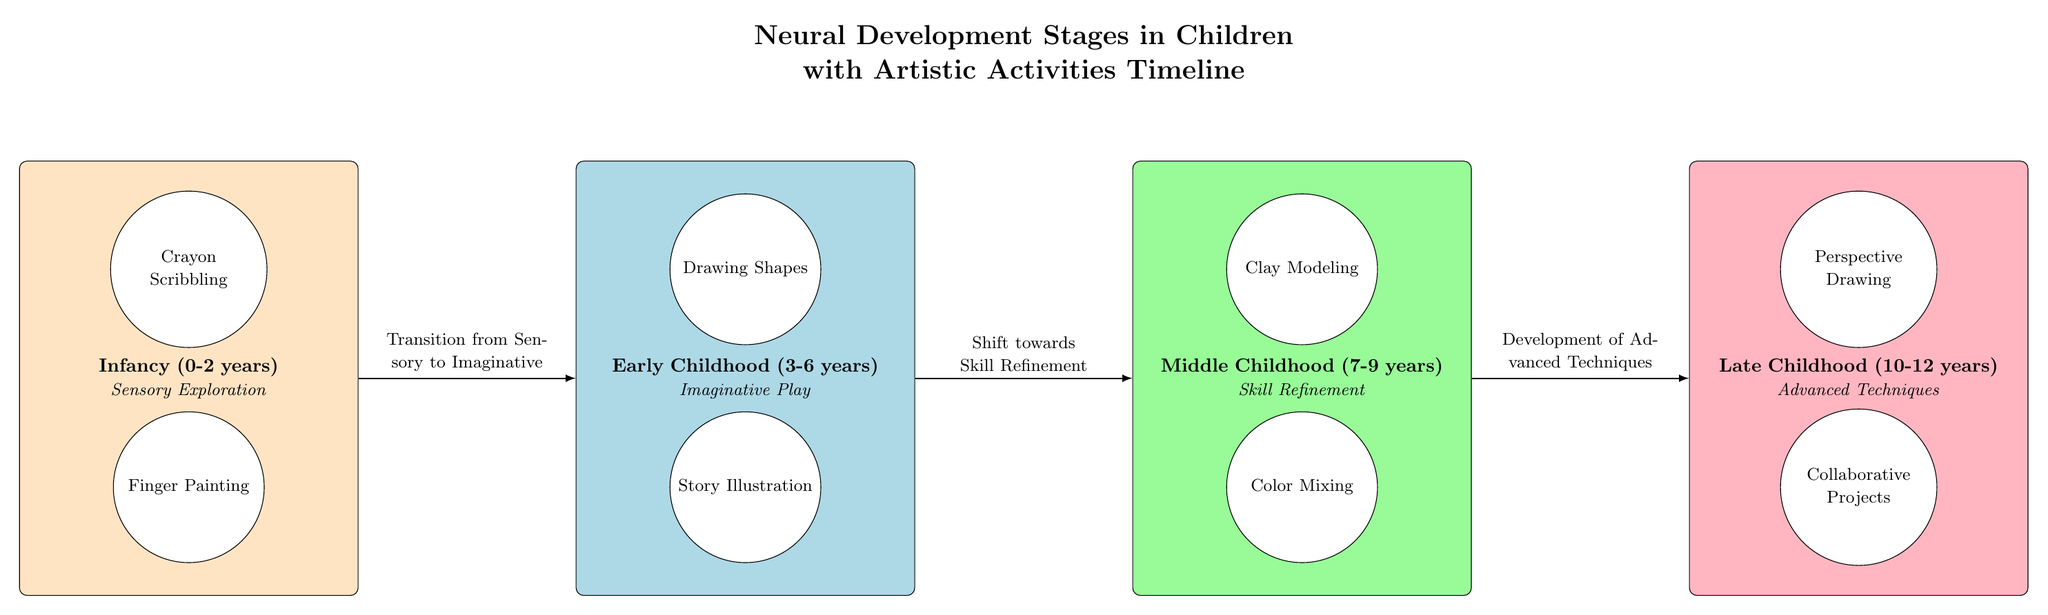What stage corresponds to ages 3-6? The diagram shows the stage "Early Childhood (3-6 years)" explicitly labeled.
Answer: Early Childhood Which activity is associated with infancy? The diagram lists "Crayon Scribbling" and "Finger Painting" under Infancy, making it clear that these activities are associated with that stage.
Answer: Crayon Scribbling What is the transition noted between the Infancy and Early Childhood stages? The diagram indicates a transition labeled "Transition from Sensory to Imaginative" between the Infancy and Early Childhood stages, clarifying the nature of this transition.
Answer: Transition from Sensory to Imaginative How many activities are listed for the Middle Childhood stage? The diagram contains two activities listed under the Middle Childhood stage: "Clay Modeling" and "Color Mixing." This indicates that there are two activities in total for this stage.
Answer: 2 What is the main focus of activities in Late Childhood? The diagram states that the main focus in Late Childhood (10-12 years) is "Advanced Techniques," which is also reflected in the associated activities.
Answer: Advanced Techniques Which two activities are listed under Early Childhood? The diagram lists "Drawing Shapes" and "Story Illustration" as the two activities under the Early Childhood stage, hence directly answering the question.
Answer: Drawing Shapes, Story Illustration What connects the Early Childhood and Middle Childhood stages? The diagram specifies a shift labeled "Shift towards Skill Refinement" connecting the Early Childhood stage to the Middle Childhood stage, indicating the relationship between these stages.
Answer: Shift towards Skill Refinement What is the color representing the Infancy stage? The diagram colors the Infancy stage with an RGB color of (255, 228, 196), which is a specific light color indicative of this developmental stage.
Answer: RGB(255, 228, 196) Which activity involves collaboration in Late Childhood? The diagram identifies "Collaborative Projects" as an activity specifically listed under the Late Childhood stage, thus providing a direct answer to the question.
Answer: Collaborative Projects 